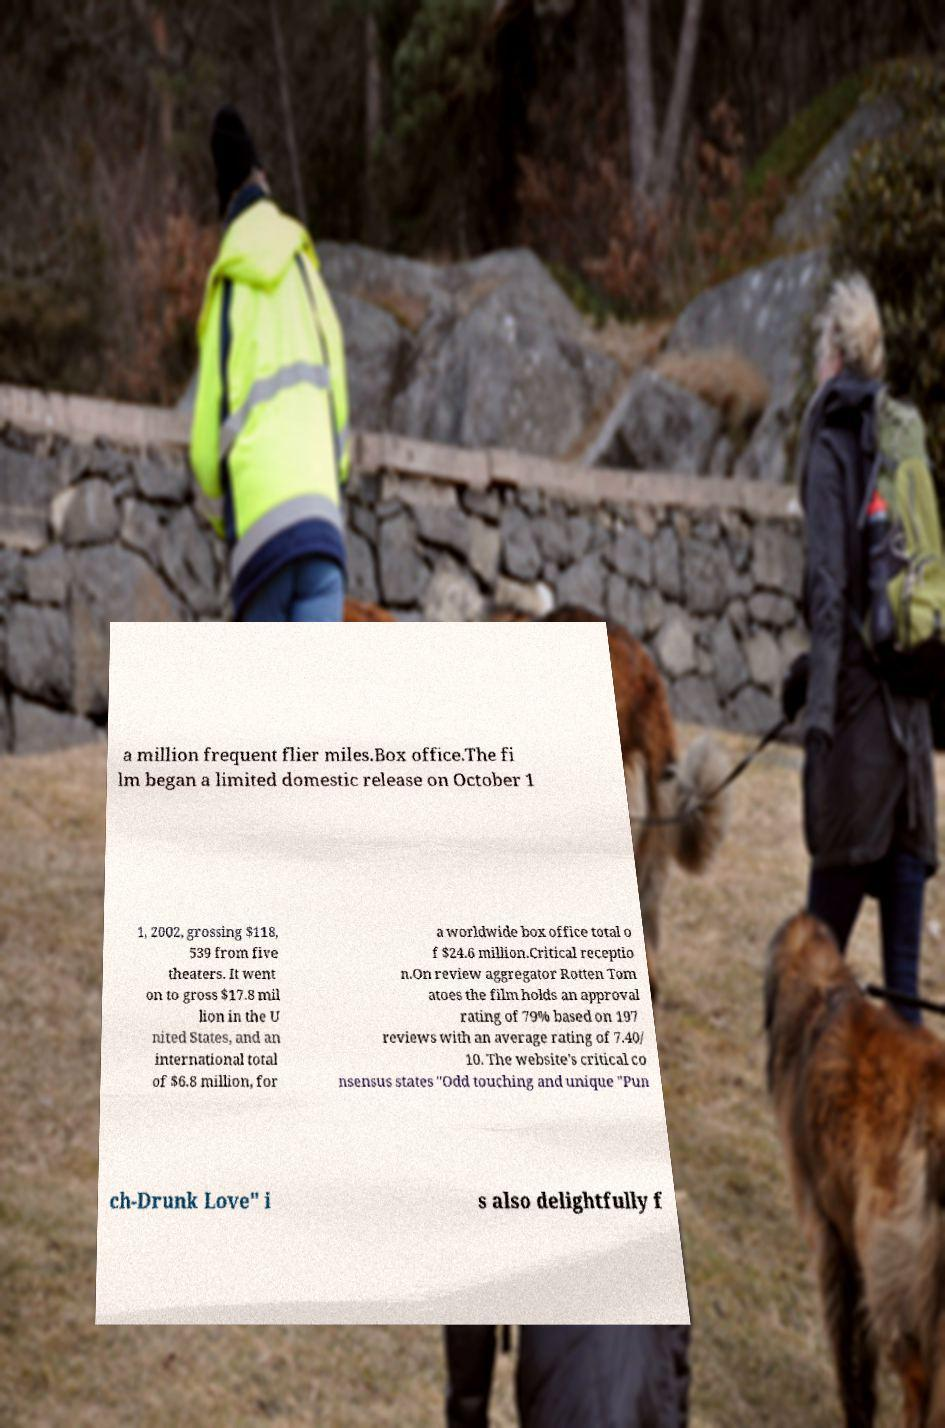I need the written content from this picture converted into text. Can you do that? a million frequent flier miles.Box office.The fi lm began a limited domestic release on October 1 1, 2002, grossing $118, 539 from five theaters. It went on to gross $17.8 mil lion in the U nited States, and an international total of $6.8 million, for a worldwide box office total o f $24.6 million.Critical receptio n.On review aggregator Rotten Tom atoes the film holds an approval rating of 79% based on 197 reviews with an average rating of 7.40/ 10. The website's critical co nsensus states "Odd touching and unique "Pun ch-Drunk Love" i s also delightfully f 